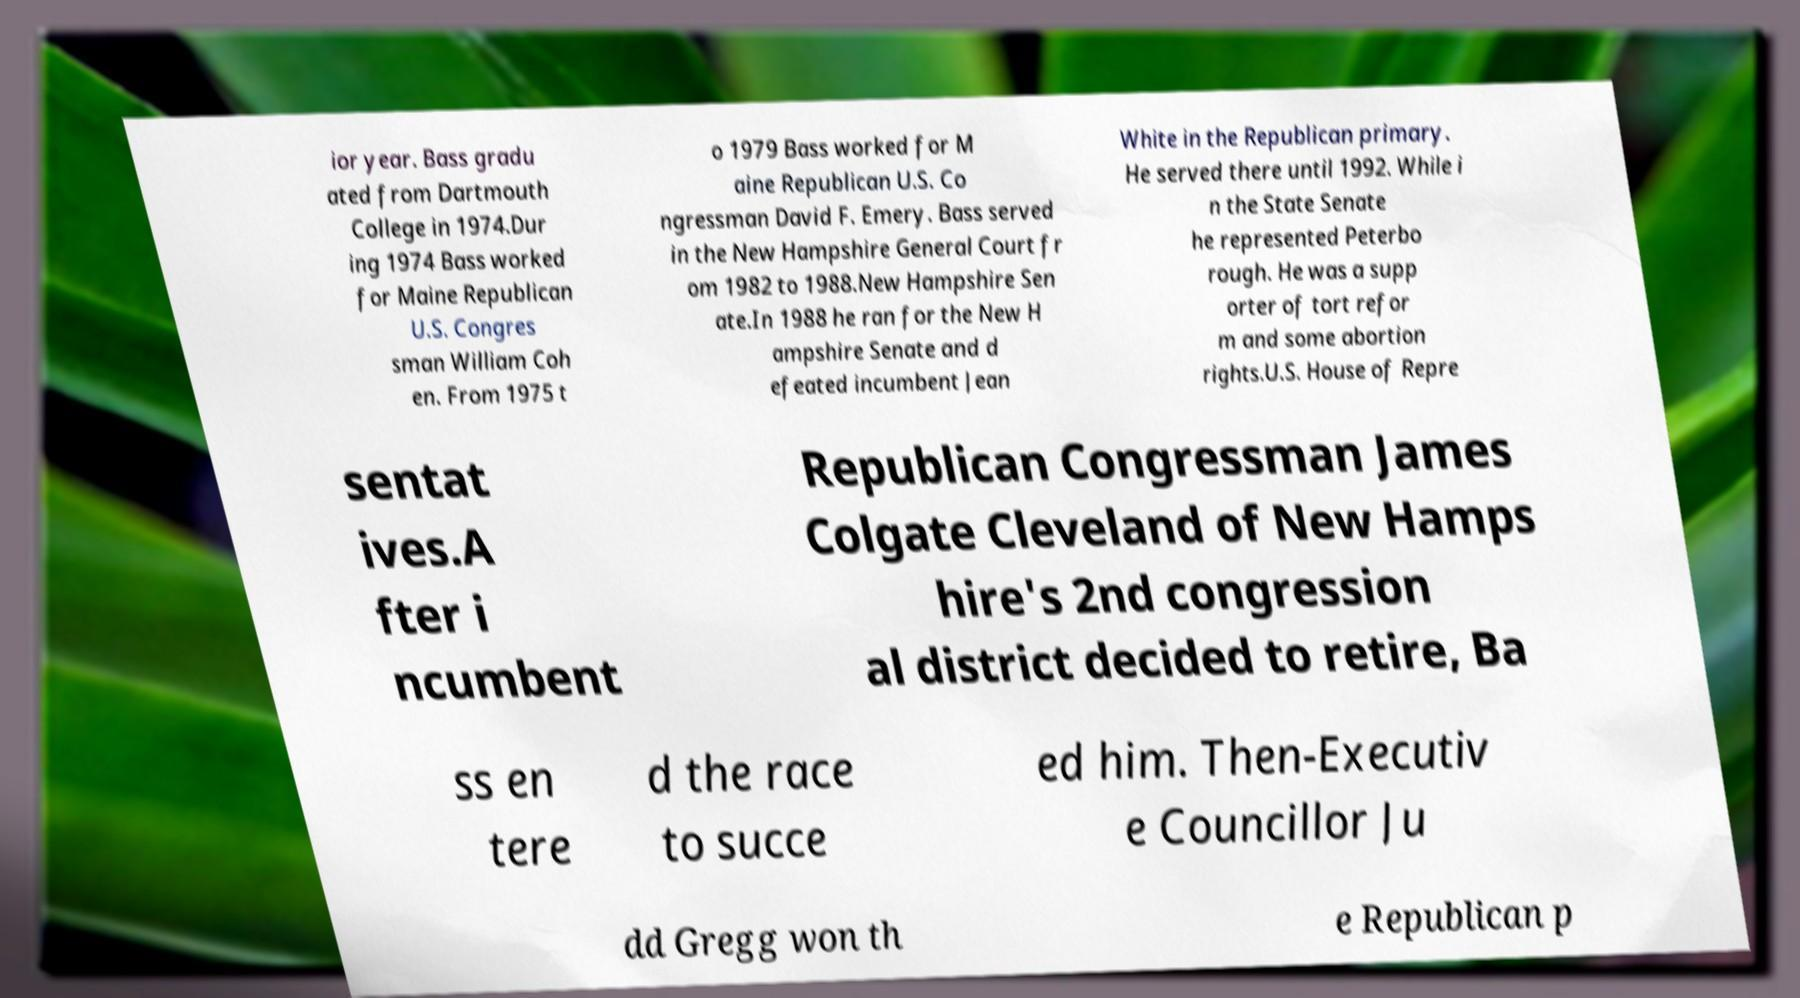Can you accurately transcribe the text from the provided image for me? ior year. Bass gradu ated from Dartmouth College in 1974.Dur ing 1974 Bass worked for Maine Republican U.S. Congres sman William Coh en. From 1975 t o 1979 Bass worked for M aine Republican U.S. Co ngressman David F. Emery. Bass served in the New Hampshire General Court fr om 1982 to 1988.New Hampshire Sen ate.In 1988 he ran for the New H ampshire Senate and d efeated incumbent Jean White in the Republican primary. He served there until 1992. While i n the State Senate he represented Peterbo rough. He was a supp orter of tort refor m and some abortion rights.U.S. House of Repre sentat ives.A fter i ncumbent Republican Congressman James Colgate Cleveland of New Hamps hire's 2nd congression al district decided to retire, Ba ss en tere d the race to succe ed him. Then-Executiv e Councillor Ju dd Gregg won th e Republican p 